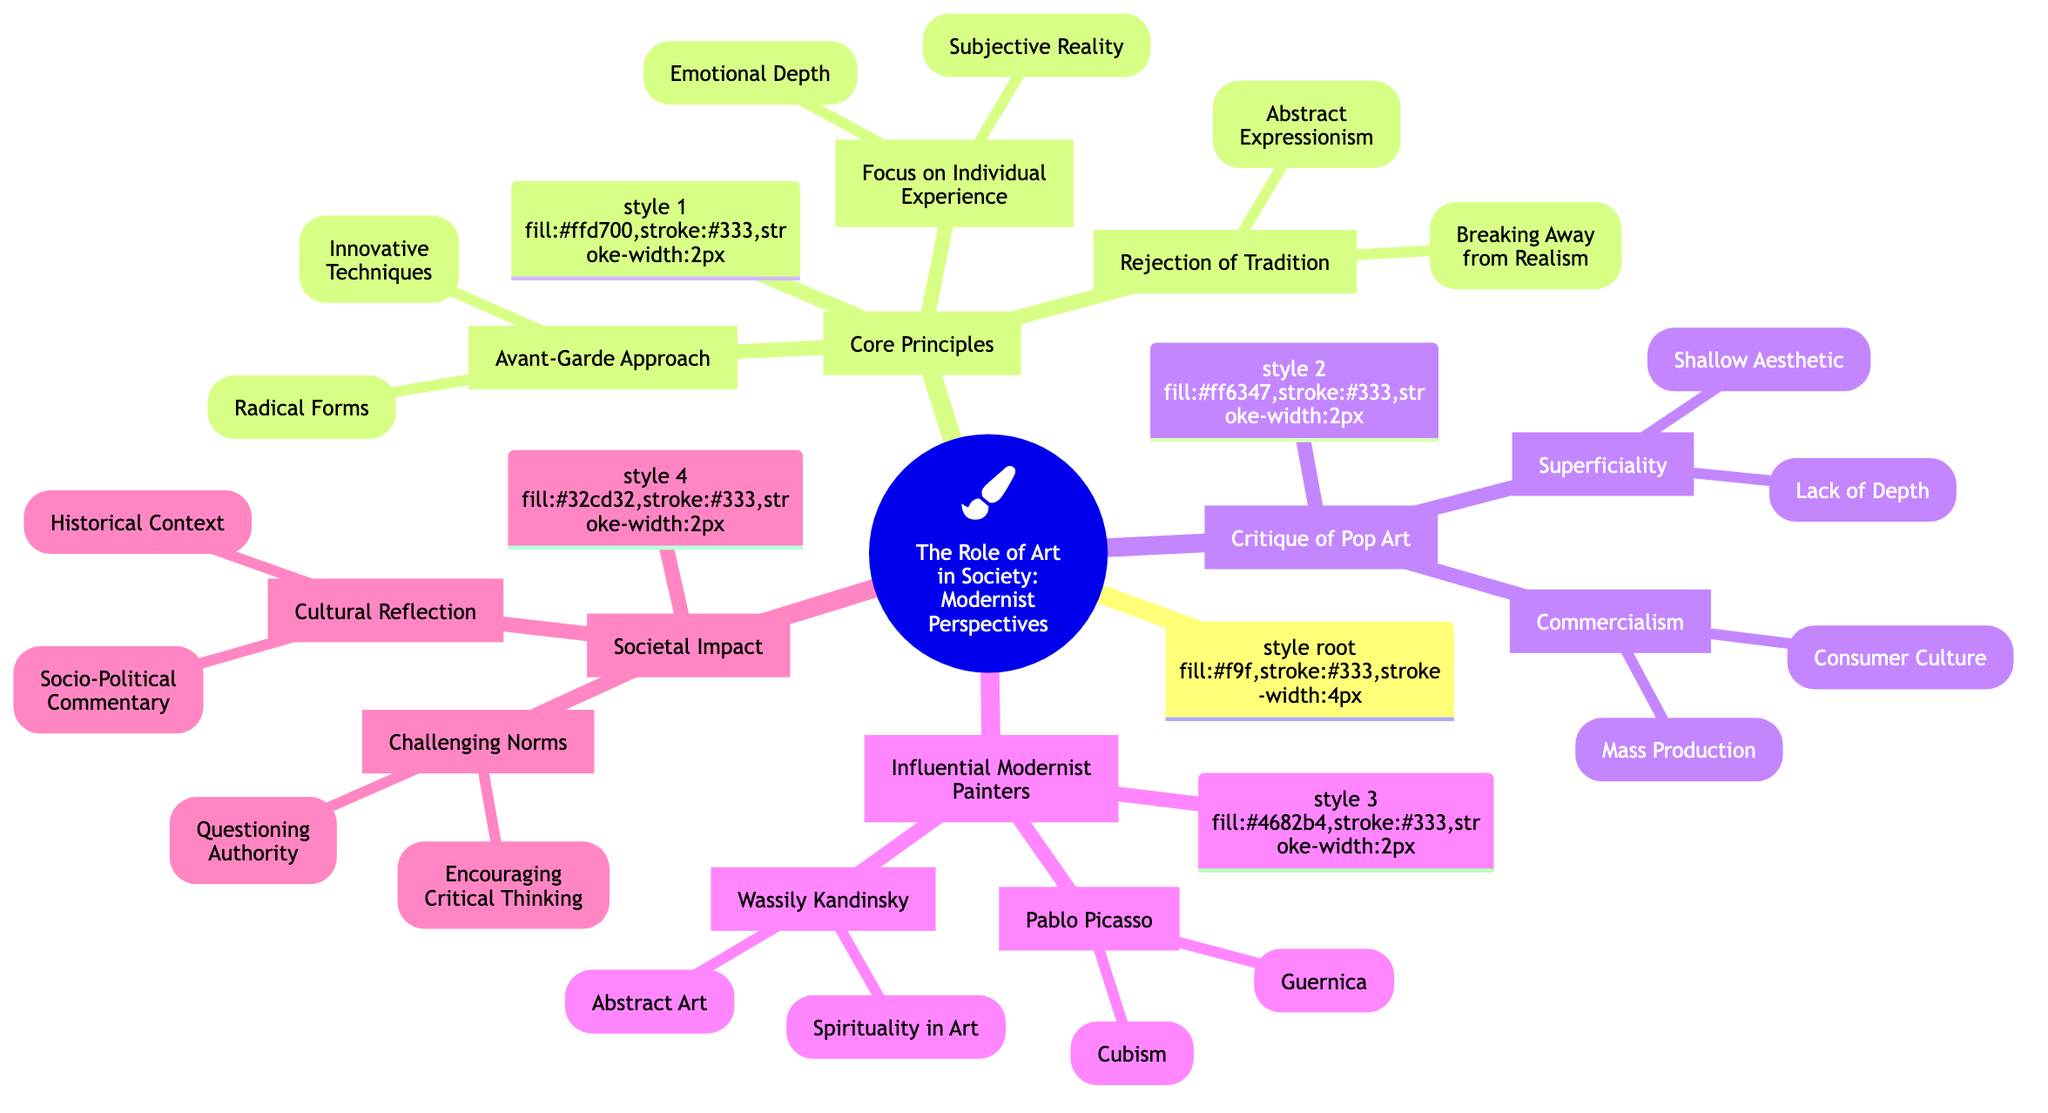What are the three core principles of Modernist perspectives on art in society? The diagram lists three core principles under the "Core Principles" node: "Rejection of Tradition," "Avant-Garde Approach," and "Focus on Individual Experience."
Answer: Rejection of Tradition, Avant-Garde Approach, Focus on Individual Experience What is the first sub-element under "Critique of Pop Art"? The "Critique of Pop Art" section has two main sub-elements: "Commercialism" and "Superficiality." The first listed sub-element is "Commercialism."
Answer: Commercialism How many influential Modernist painters are listed in the diagram? Under the "Influential Modernist Painters" node, there are two main sub-elements: "Pablo Picasso" and "Wassily Kandinsky." Therefore, there are two influential Modernist painters listed.
Answer: 2 Which sub-element focuses on questioning societal norms? The "Challenging Norms" sub-element is found under the "Societal Impact" section. It explicitly addresses the need for questioning authority and encouraging critical thinking in society.
Answer: Challenging Norms What aspect of the role of art does "Emotional Depth" belong to? "Emotional Depth" is a sub-element of the "Focus on Individual Experience" category, which pertains to how Modernist art emphasizes personal emotional responses and experiences.
Answer: Focus on Individual Experience Which painter is associated with "Guernica"? "Guernica" is specifically listed as a sub-element under "Pablo Picasso." This major work is a significant piece that reflects emotions tied to war and suffering.
Answer: Pablo Picasso What does "Mass Production" critique in the context of Pop Art? "Mass Production" is a sub-element under "Commercialism," which critiques how art becomes a product for mass consumption, critiquing the commercial aspect of the Pop Art movement.
Answer: Commercialism Identify a key concept that challenges authority within the societal aspect of the diagram. The "Questioning Authority" sub-element falls under "Challenging Norms," signifying a critical examination and challenge of established authorities through art.
Answer: Questioning Authority What type of art movement does "Abstract Expressionism" model? "Abstract Expressionism" is included as a sub-element under "Rejection of Tradition," representing a movement that sought to move beyond traditional representation in art.
Answer: Rejection of Tradition 